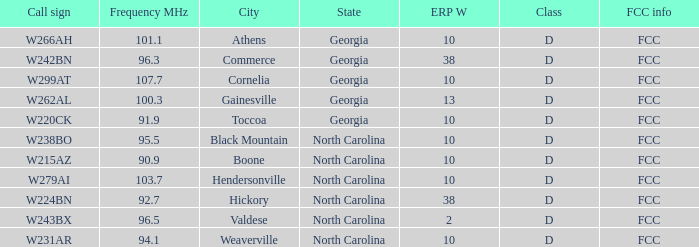What city has larger than 94.1 as a frequency? Athens, Georgia, Commerce, Georgia, Cornelia, Georgia, Gainesville, Georgia, Black Mountain, North Carolina, Hendersonville, North Carolina, Valdese, North Carolina. 